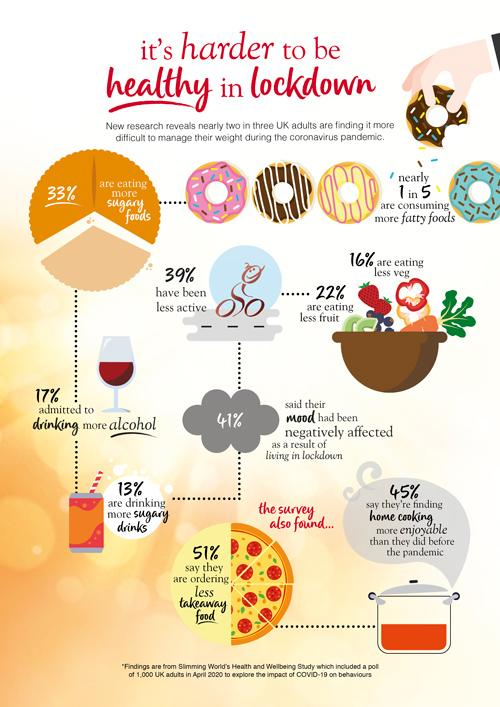Mention a couple of crucial points in this snapshot. During lockdown, it was reported that a significant percentage of people did not consume more sugary foods. According to a recent survey, a majority of people, or 55%, find that home cooking is not more enjoyable than before the pandemic. During lockdown, a significant proportion of individuals did not become less active, with 61% reporting similar levels of physical activity as before the restrictions were imposed. According to recent studies, a significant percentage of people, approximately 80%, have chosen not to consume more fatty foods during lockdown. The color of the text in the heading is either red or black. 